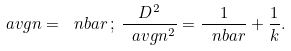<formula> <loc_0><loc_0><loc_500><loc_500>\ a v g n = \ n b a r \, ; \, \frac { D ^ { 2 } } { \ a v g n ^ { 2 } } = \frac { 1 } { \ n b a r } + \frac { 1 } { k } .</formula> 